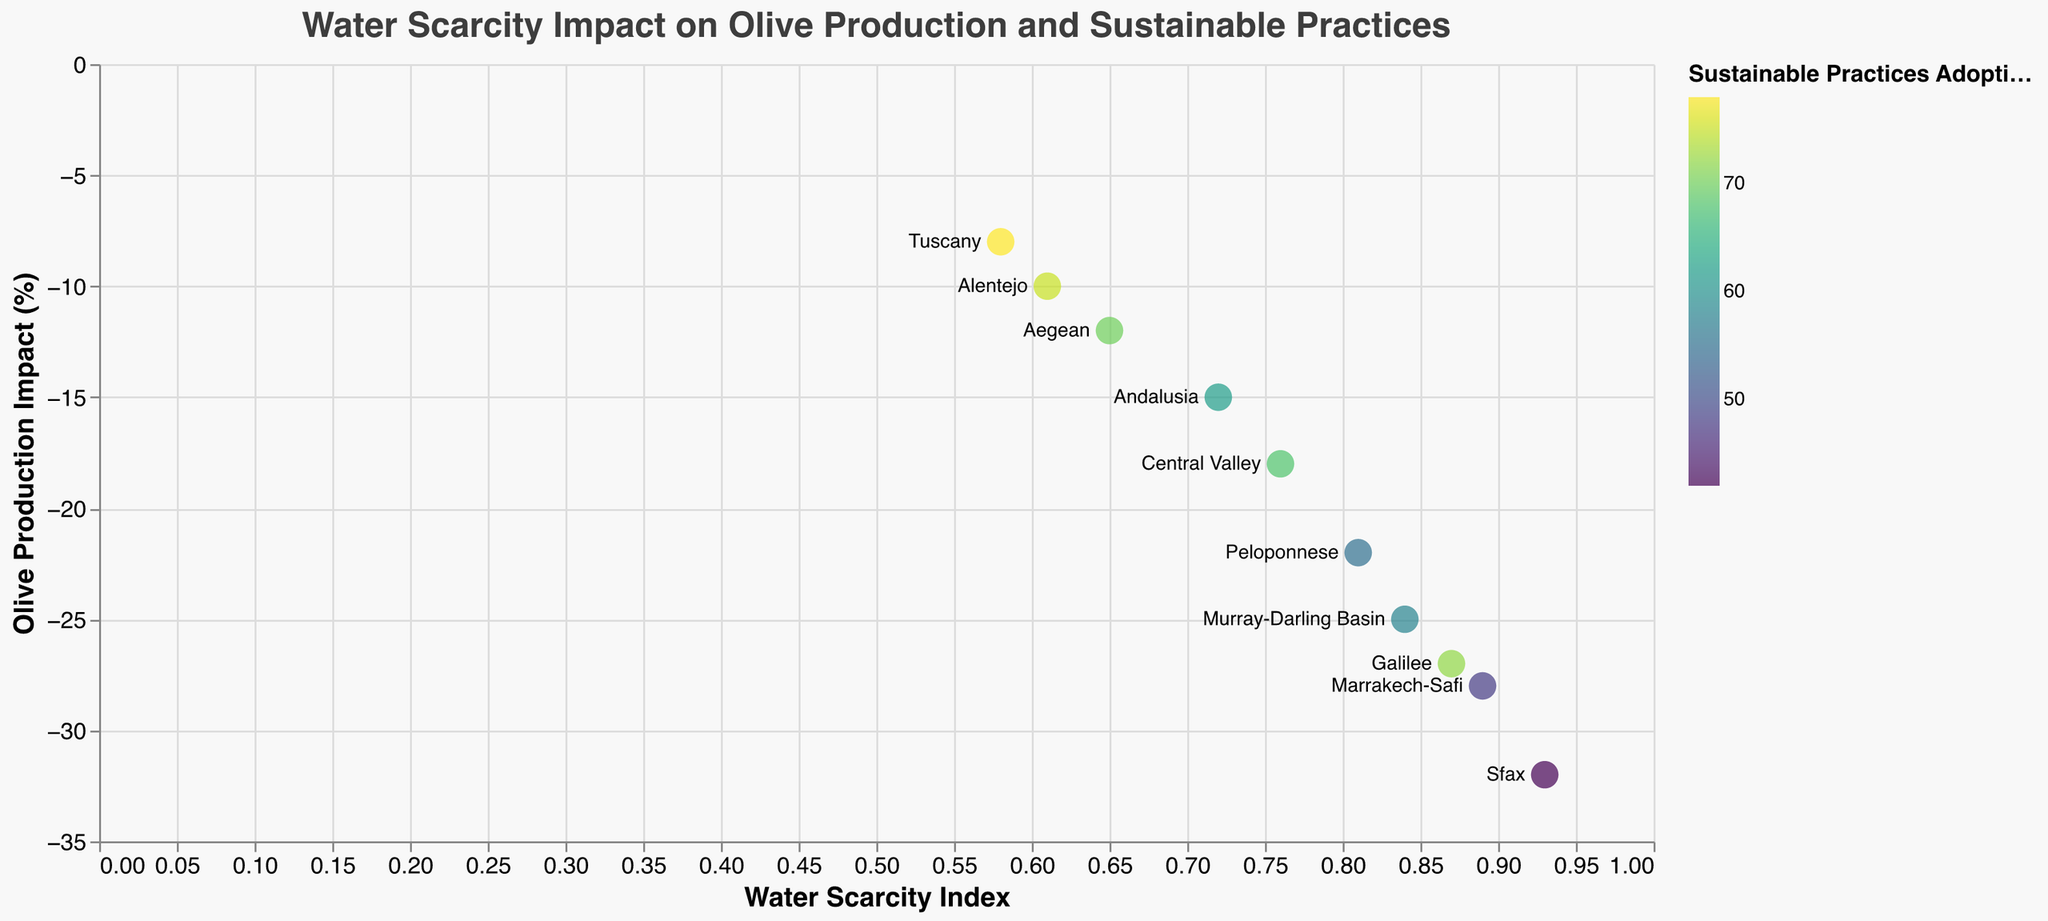What's the water scarcity index for the Peloponnese region in Greece? Look at the tooltip or data point indicating Greece, Peloponnese to find the water scarcity index value.
Answer: 0.81 Which region has the highest adoption of sustainable practices? Compare the color intensity of the circles which represent the adoption of sustainable practices, finding the one with the highest percentage in the tooltip.
Answer: Tuscany What is the correlation between water scarcity and olive production impact? Observe the general trend of the relationship between the Water Scarcity Index (x-axis) and Olive Production Impact (y-axis). As water scarcity increases, note the direction (negative) of olive production impact.
Answer: Negative correlation Which region's olive production is least affected by water scarcity? Look at the point closest to the horizontal axis (y = 0) to identify the region with the smallest negative impact on olive production.
Answer: Tuscany How does the olive production impact in Central Valley, California compare to that in Andalusia, Spain? Compare the y-axis values (Olive Production Impact) for the points representing Central Valley, California and Andalusia, Spain.
Answer: Central Valley: -18, Andalusia: -15 What is the average adoption of sustainable practices across all regions? Sum the Sustainable Practices Adoption percentages of all regions and divide by the number of regions. (62 + 78 + 55 + 70 + 48 + 42 + 75 + 68 + 58 + 72) / 10 = 62.8
Answer: 62.8 Which region has the highest Water Scarcity Index? Compare Water Scarcity Index values from the tooltips, identifying the highest one.
Answer: Sfax, Tunisia Is there a region with both high water scarcity and high adoption of sustainable practices? Look for a point with a high x-coordinate (Water Scarcity Index) and intense color representing high sustainable practices adoption.
Answer: Galilee, Israel What is the difference in water scarcity index between Tuscany and Sfax? Subtract the water scarcity index of Tuscany from that of Sfax: 0.93 - 0.58.
Answer: 0.35 How does the olive production impact in the Murray-Darling Basin, Australia compare to that in Marrakech-Safi, Morocco? Compare the y-axis values for the points representing Murray-Darling Basin, Australia, and Marrakech-Safi, Morocco.
Answer: Murray-Darling Basin: -25, Marrakech-Safi: -28 